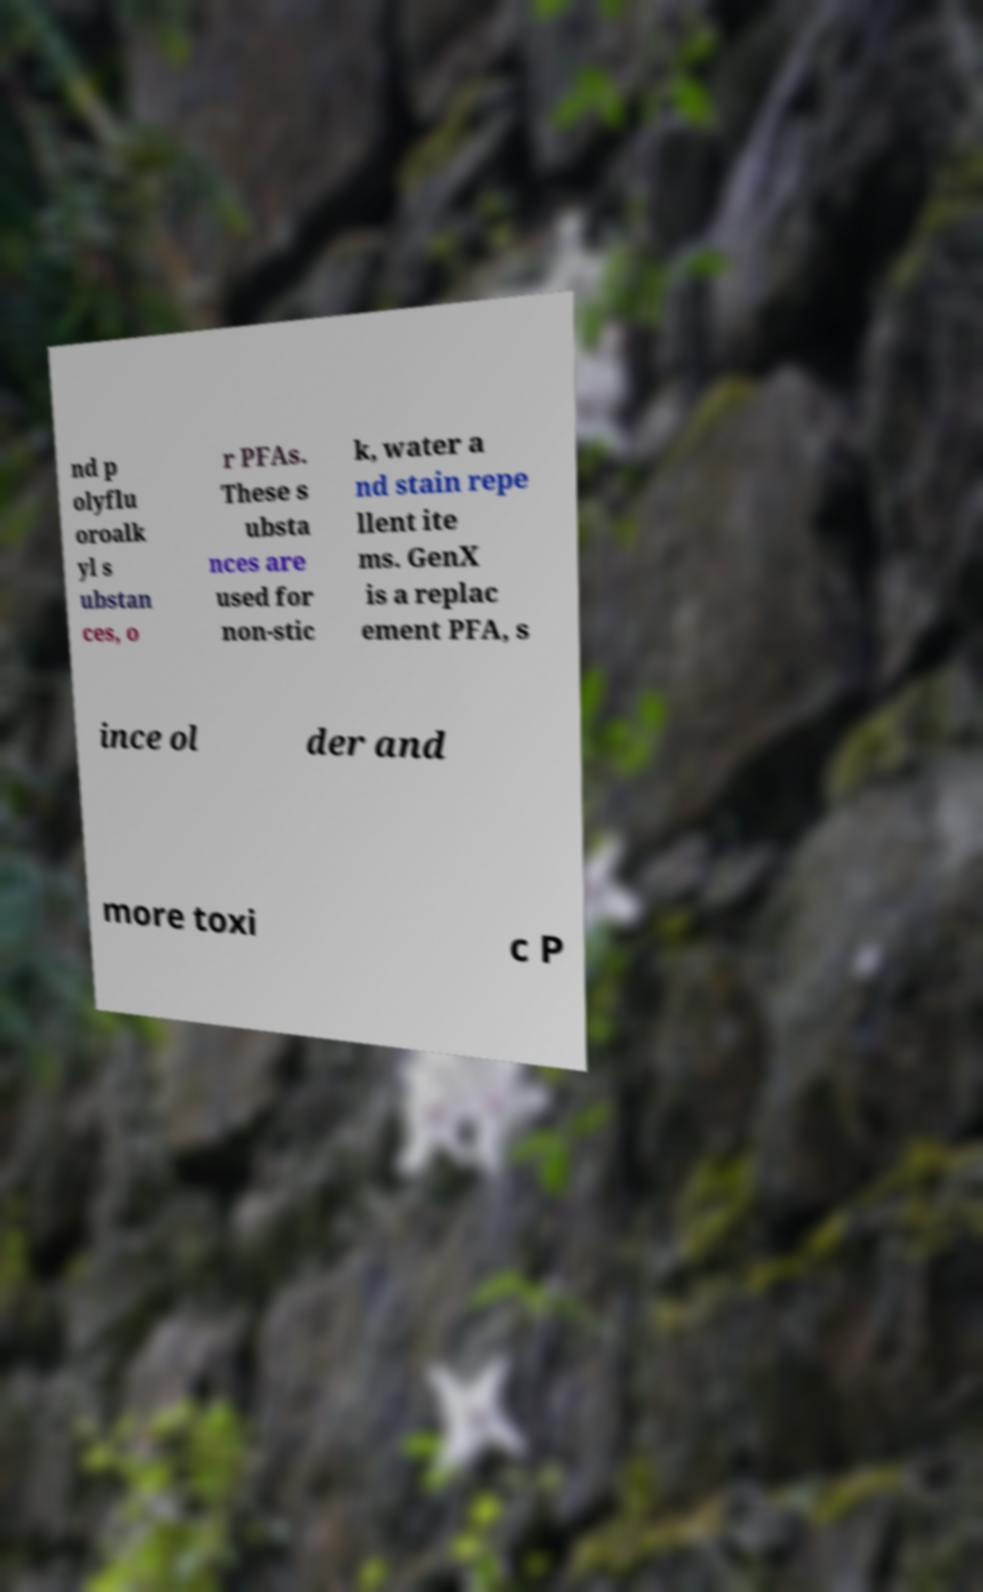Could you extract and type out the text from this image? nd p olyflu oroalk yl s ubstan ces, o r PFAs. These s ubsta nces are used for non-stic k, water a nd stain repe llent ite ms. GenX is a replac ement PFA, s ince ol der and more toxi c P 